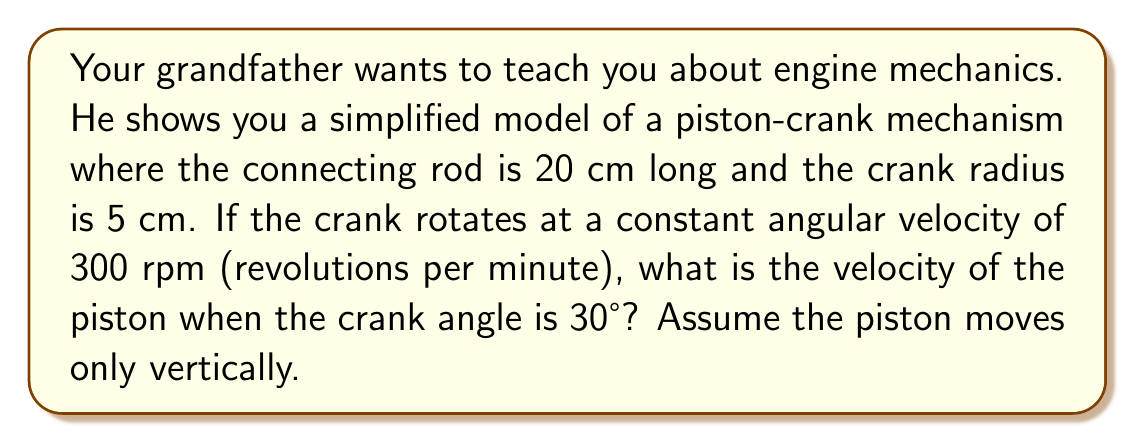Help me with this question. Let's approach this step-by-step:

1) First, we need to convert the angular velocity from rpm to radians per second:
   $$ \omega = 300 \text{ rpm} \times \frac{2\pi \text{ rad}}{1 \text{ rev}} \times \frac{1 \text{ min}}{60 \text{ s}} = 10\pi \text{ rad/s} $$

2) Let's define our variables:
   $r$ = crank radius = 5 cm
   $l$ = connecting rod length = 20 cm
   $\theta$ = crank angle = 30°

3) The position of the piston can be described by:
   $$ y = r \cos\theta + \sqrt{l^2 - r^2\sin^2\theta} $$

4) The velocity of the piston is the derivative of this position with respect to time:
   $$ v = \frac{dy}{dt} = -r\omega\sin\theta - \frac{r^2\omega\sin\theta\cos\theta}{\sqrt{l^2 - r^2\sin^2\theta}} $$

5) Now, let's substitute our values:
   $$ v = -5 \cdot 10\pi \cdot \sin30° - \frac{5^2 \cdot 10\pi \cdot \sin30° \cdot \cos30°}{\sqrt{20^2 - 5^2\sin^230°}} $$

6) Simplify:
   $$ v = -25\pi \cdot 0.5 - \frac{125\pi \cdot 0.5 \cdot 0.866}{\sqrt{400 - 25 \cdot 0.25}} $$
   $$ v = -12.5\pi - \frac{54.125\pi}{\sqrt{393.75}} $$
   $$ v = -12.5\pi - 2.728\pi $$
   $$ v = -15.228\pi \text{ cm/s} $$

7) Convert to m/s:
   $$ v = -15.228\pi \cdot 0.01 = -0.4782\pi \text{ m/s} \approx -1.502 \text{ m/s} $$

The negative sign indicates that the piston is moving downward at this instant.
Answer: $-1.502 \text{ m/s}$ 